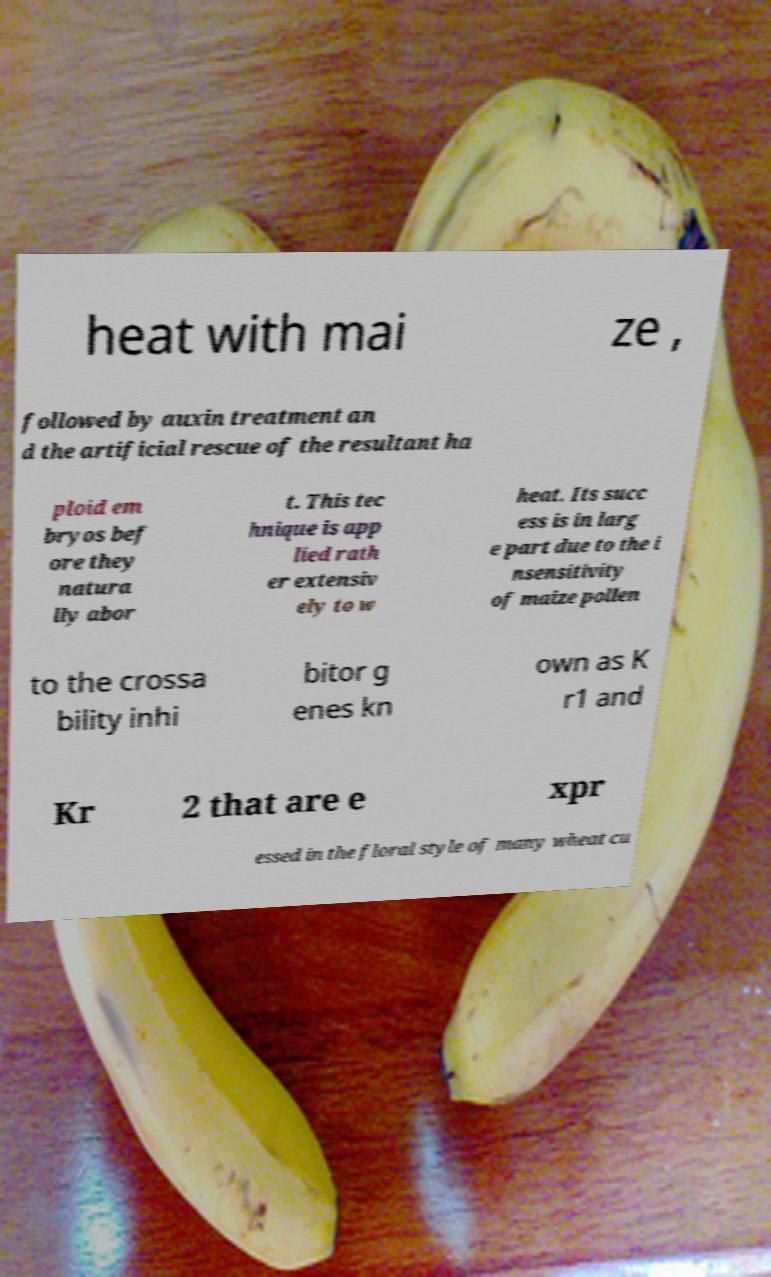There's text embedded in this image that I need extracted. Can you transcribe it verbatim? heat with mai ze , followed by auxin treatment an d the artificial rescue of the resultant ha ploid em bryos bef ore they natura lly abor t. This tec hnique is app lied rath er extensiv ely to w heat. Its succ ess is in larg e part due to the i nsensitivity of maize pollen to the crossa bility inhi bitor g enes kn own as K r1 and Kr 2 that are e xpr essed in the floral style of many wheat cu 